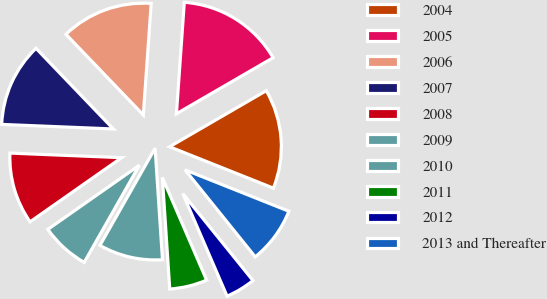<chart> <loc_0><loc_0><loc_500><loc_500><pie_chart><fcel>2004<fcel>2005<fcel>2006<fcel>2007<fcel>2008<fcel>2009<fcel>2010<fcel>2011<fcel>2012<fcel>2013 and Thereafter<nl><fcel>14.4%<fcel>15.51%<fcel>13.29%<fcel>12.18%<fcel>10.38%<fcel>7.05%<fcel>9.27%<fcel>5.43%<fcel>4.32%<fcel>8.16%<nl></chart> 